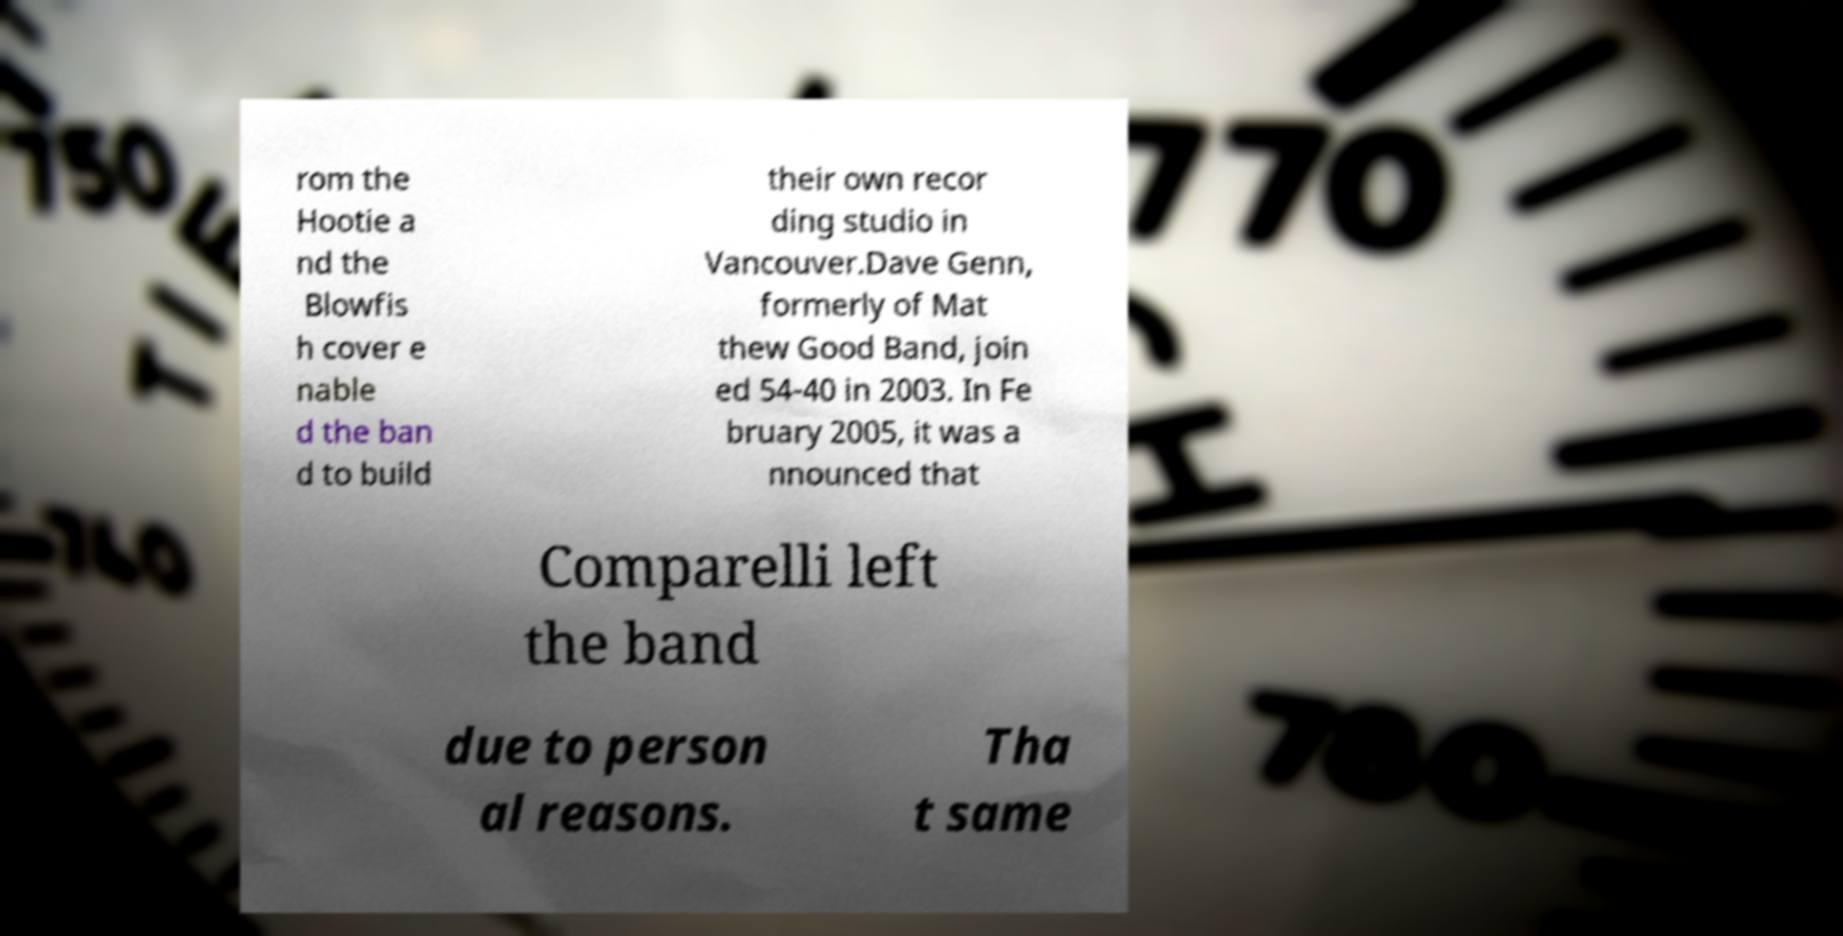Please identify and transcribe the text found in this image. rom the Hootie a nd the Blowfis h cover e nable d the ban d to build their own recor ding studio in Vancouver.Dave Genn, formerly of Mat thew Good Band, join ed 54-40 in 2003. In Fe bruary 2005, it was a nnounced that Comparelli left the band due to person al reasons. Tha t same 